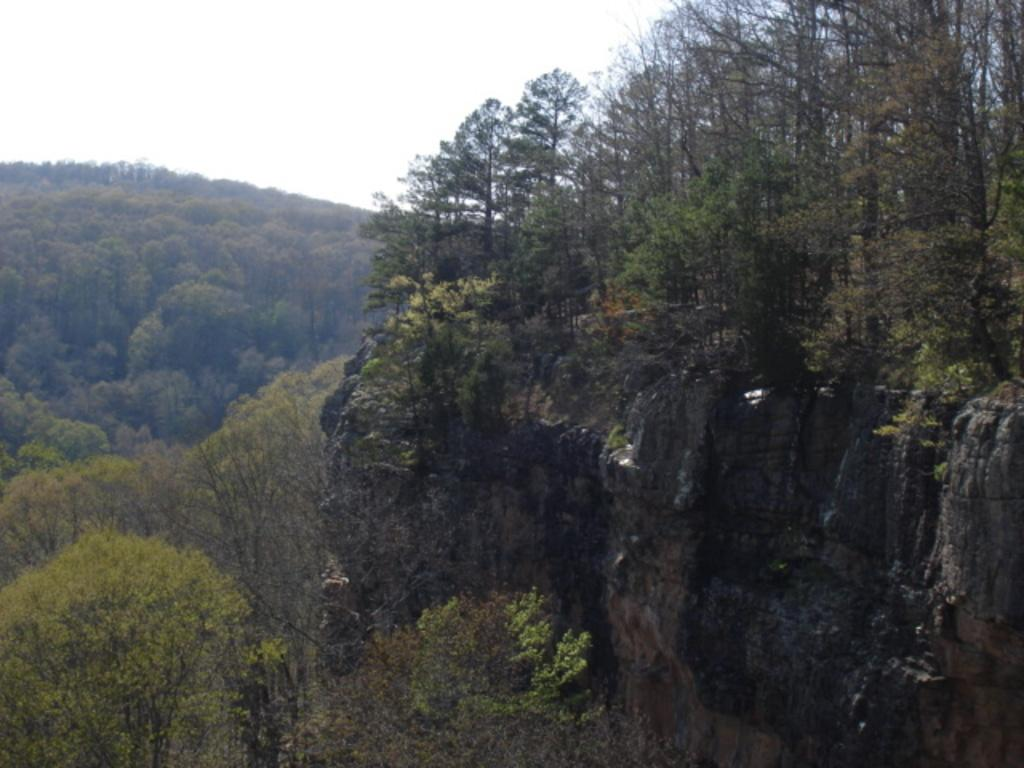What type of view is shown in the image? The image is an outside view. What can be seen on the right side of the image? There is a rock on the right side of the image. What is visible in the background of the image? There are many trees in the background of the image. What is visible at the top of the image? The sky is visible at the top of the image. How many caps are visible on the trees in the image? There are no caps visible on the trees in the image; it features a rock and trees in an outside view. 